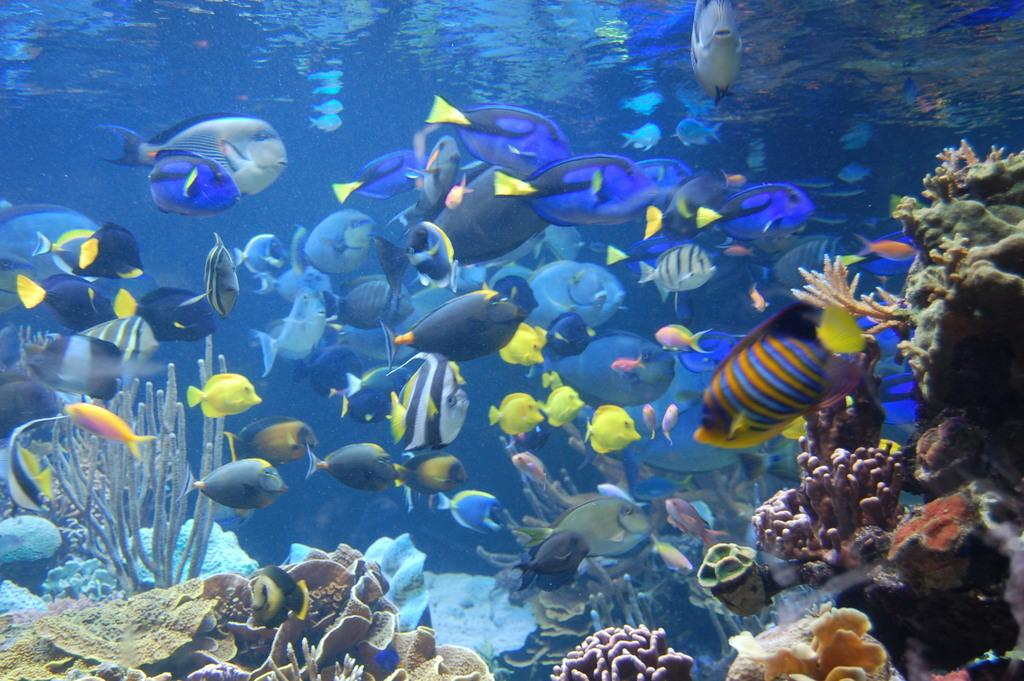What type of animals can be seen in the image? There are fishes in the image. What other elements can be seen in the image besides the fishes? There are water plants in the image. Where is the tent located in the image? There is no tent present in the image. How many groups of fishes can be seen in the image? The image does not indicate the number of groups of fishes; it only shows the presence of fishes. 